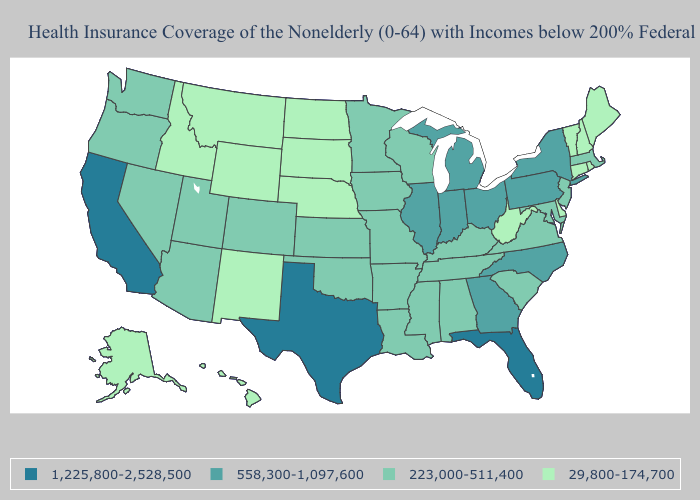Which states have the highest value in the USA?
Be succinct. California, Florida, Texas. Among the states that border Oklahoma , does Texas have the lowest value?
Answer briefly. No. Name the states that have a value in the range 1,225,800-2,528,500?
Give a very brief answer. California, Florida, Texas. Does Florida have the highest value in the USA?
Answer briefly. Yes. What is the value of Maryland?
Give a very brief answer. 223,000-511,400. Which states hav the highest value in the Northeast?
Concise answer only. New York, Pennsylvania. Does Wyoming have the lowest value in the USA?
Quick response, please. Yes. Which states have the lowest value in the USA?
Keep it brief. Alaska, Connecticut, Delaware, Hawaii, Idaho, Maine, Montana, Nebraska, New Hampshire, New Mexico, North Dakota, Rhode Island, South Dakota, Vermont, West Virginia, Wyoming. Does Nebraska have the lowest value in the MidWest?
Short answer required. Yes. Does Arizona have the highest value in the West?
Be succinct. No. Does the map have missing data?
Keep it brief. No. What is the value of Idaho?
Answer briefly. 29,800-174,700. Does Nebraska have the highest value in the MidWest?
Concise answer only. No. Name the states that have a value in the range 29,800-174,700?
Write a very short answer. Alaska, Connecticut, Delaware, Hawaii, Idaho, Maine, Montana, Nebraska, New Hampshire, New Mexico, North Dakota, Rhode Island, South Dakota, Vermont, West Virginia, Wyoming. Name the states that have a value in the range 1,225,800-2,528,500?
Write a very short answer. California, Florida, Texas. 